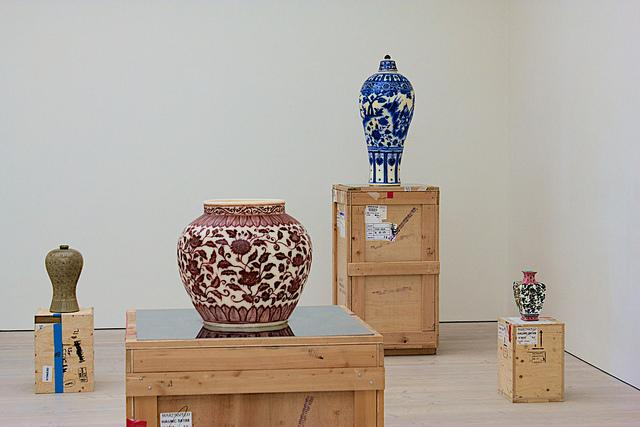What is the main color of the Chinese vase on the center right?

Choices:
A) red
B) blue
C) green
D) yellow blue 